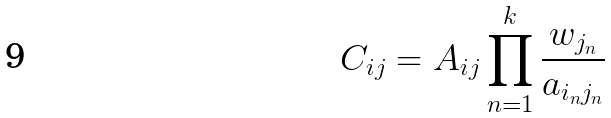<formula> <loc_0><loc_0><loc_500><loc_500>C _ { i j } = A _ { i j } \prod _ { n = 1 } ^ { k } \frac { w _ { j _ { n } } } { a _ { i _ { n } j _ { n } } }</formula> 